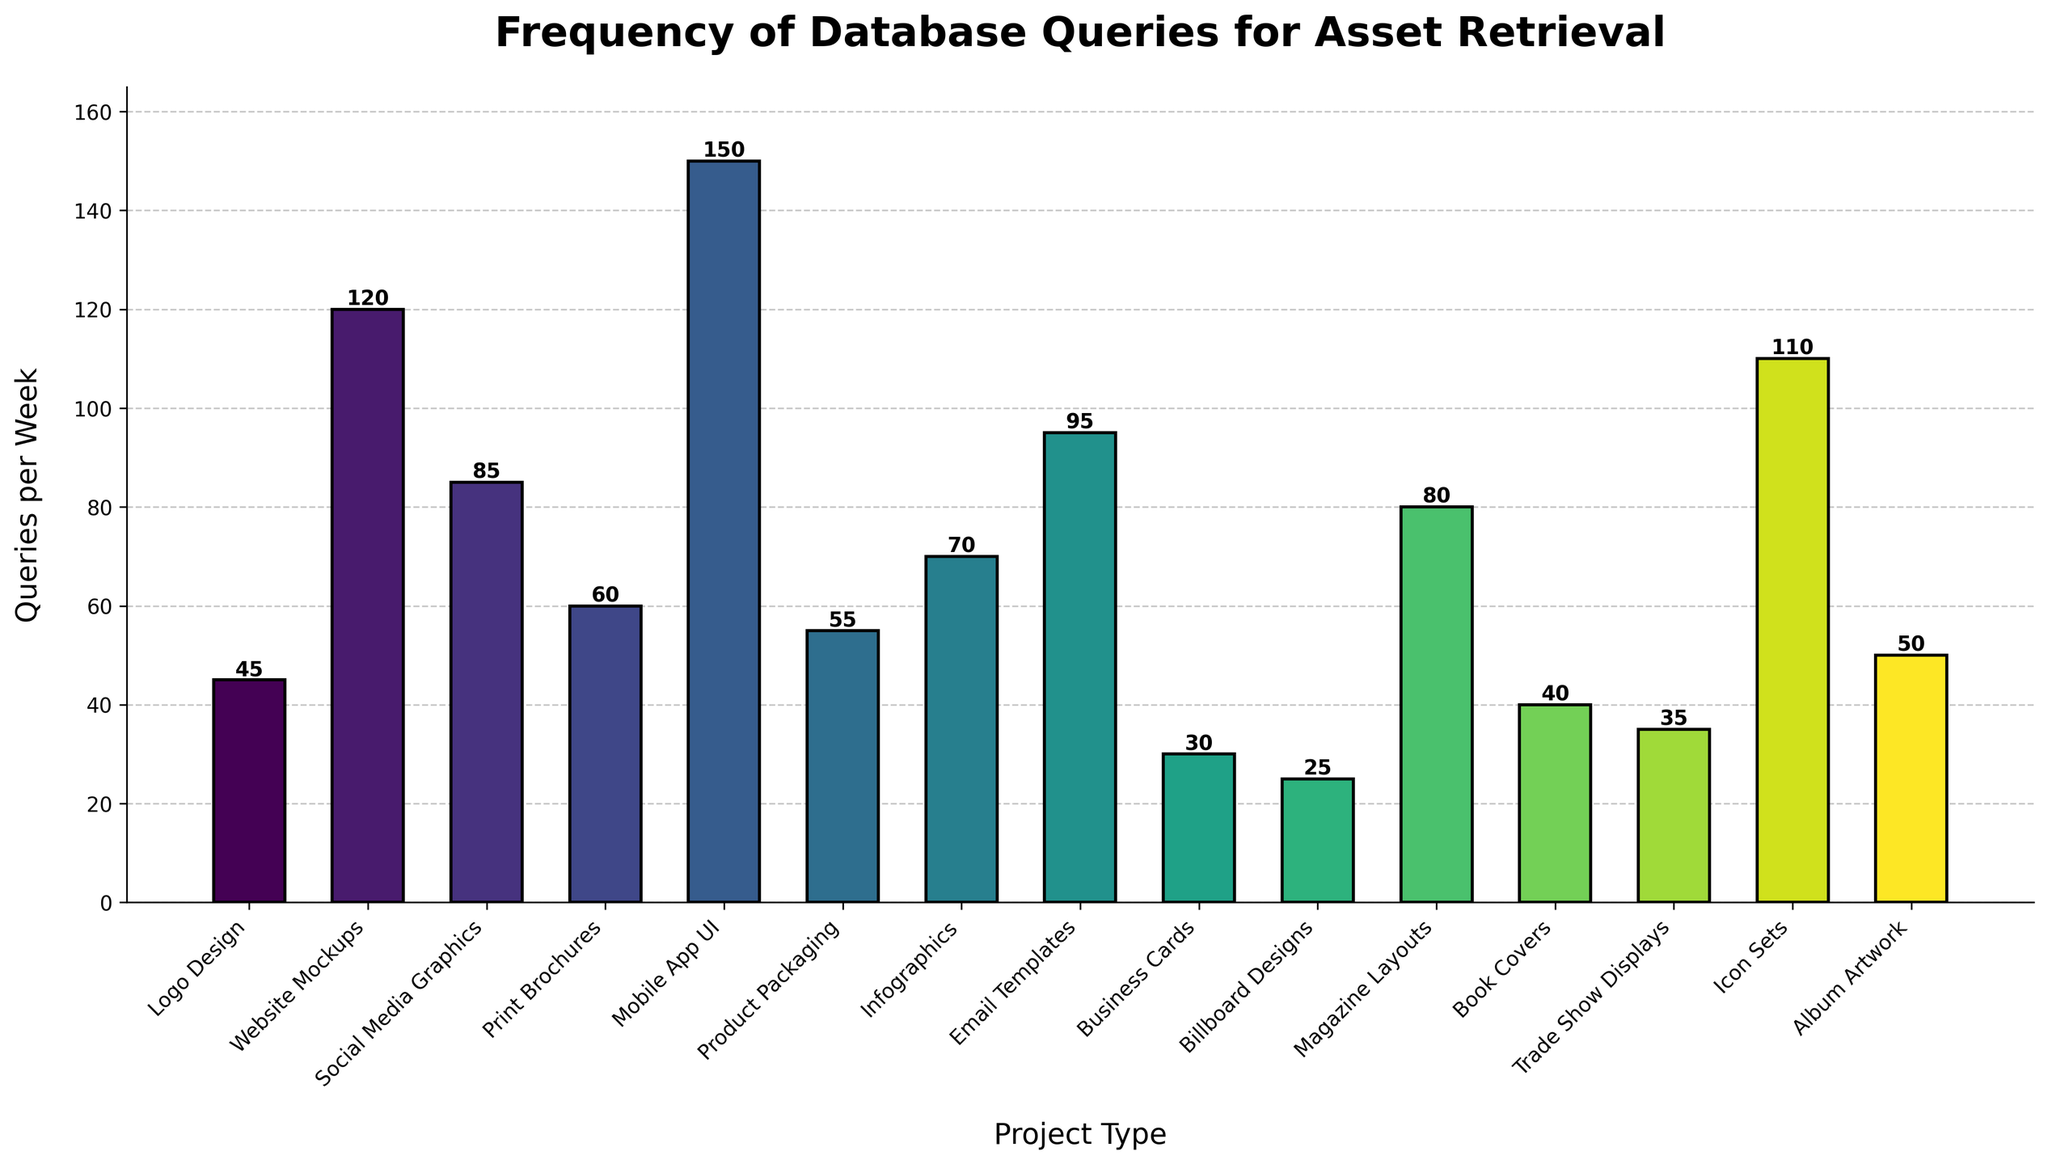What's the total number of database queries per week for Website Mockups and Mobile App UI combined? Sum the queries for Website Mockups (120) and Mobile App UI (150). 120 + 150 = 270
Answer: 270 Which project type has the fewest database queries per week? Compare the queries per week for all project types and find the minimum value. Billboard Designs has the fewest queries with 25 per week.
Answer: Billboard Designs Are there more queries for Email Templates or Infographics? Compare the queries for Email Templates (95) and Infographics (70). 95 is greater than 70, so Email Templates has more queries.
Answer: Email Templates What is the average number of queries per week for Database queries for asset retrieval across all project types? Sum up all query values and divide by the number of project types. (45 + 120 + 85 + 60 + 150 + 55 + 70 + 95 + 30 + 25 + 80 + 40 + 35 + 110 + 50) / 15 = 1050 / 15 = 70
Answer: 70 Which three project types have the highest frequency of database queries per week? Sort the project types by the number of queries and select the top three: Mobile App UI (150), Website Mockups (120), and Icon Sets (110).
Answer: Mobile App UI, Website Mockups, Icon Sets What is the difference in the number of queries between Social Media Graphics and Print Brochures? Subtract the queries for Print Brochures (60) from Social Media Graphics (85). 85 - 60 = 25
Answer: 25 Which bar appears the tallest in the chart? Visually identify the bar with the greatest height, which corresponds to the highest value of database queries per week. Mobile App UI, with 150 queries, appears the tallest.
Answer: Mobile App UI How many more queries per week do Email Templates have compared to Business Cards? Subtract the queries for Business Cards (30) from Email Templates (95). 95 - 30 = 65
Answer: 65 